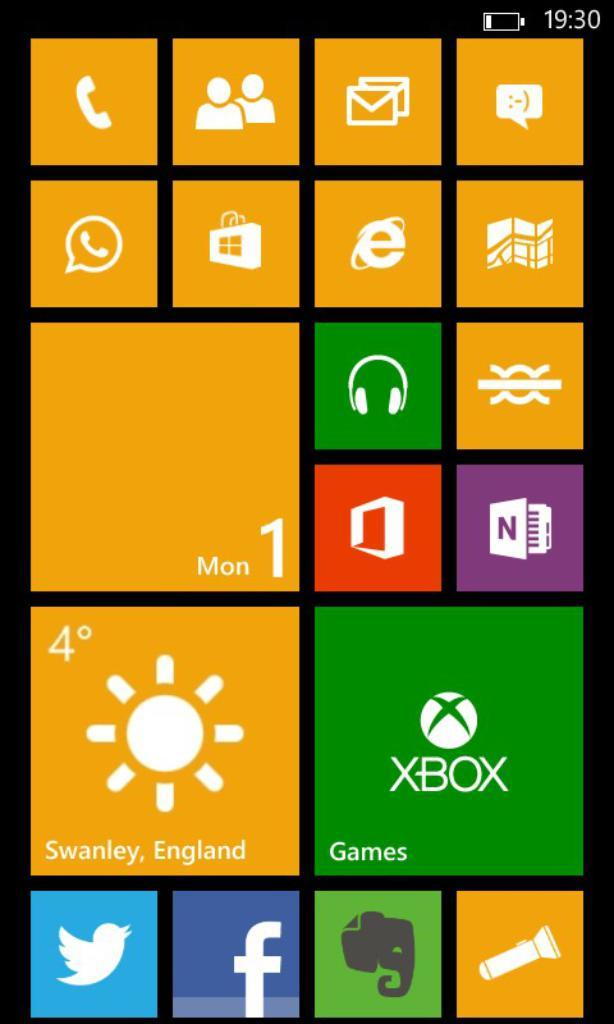<image>
Relay a brief, clear account of the picture shown. The time is currently 19:30 in Swanley, England. 